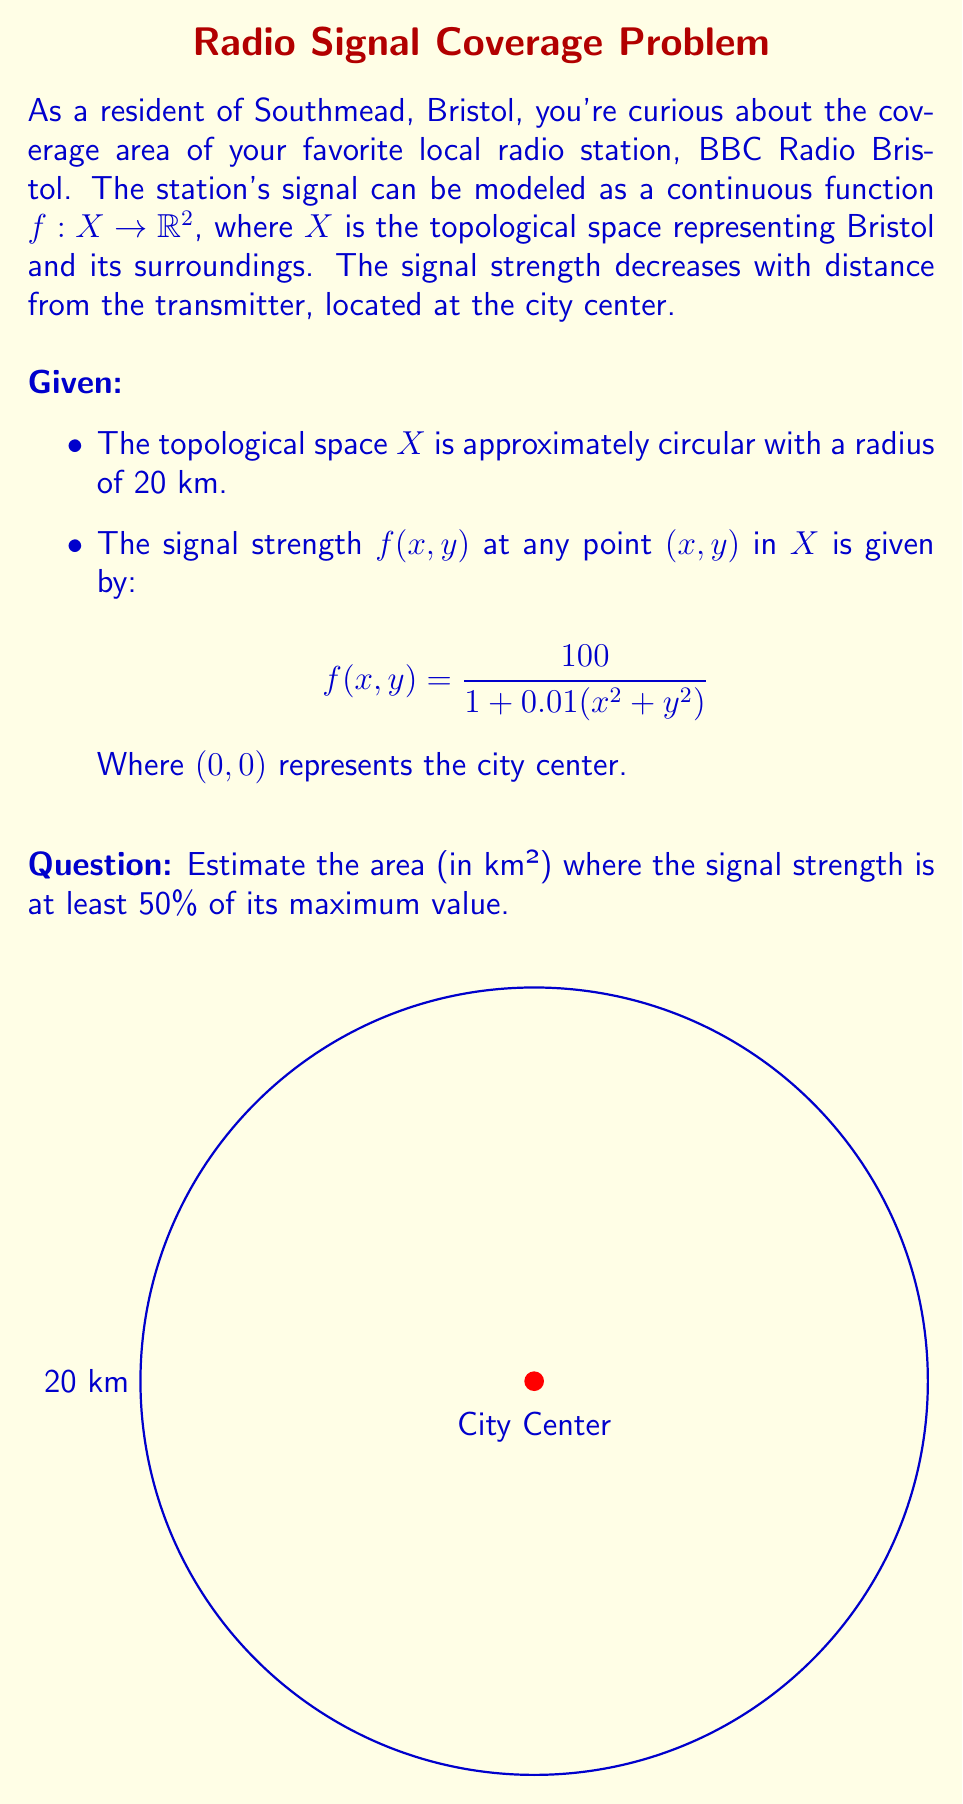Can you answer this question? Let's approach this step-by-step:

1) First, we need to find the maximum signal strength. This occurs at the city center (0,0):

   $$f(0,0) = \frac{100}{1 + 0.01(0^2 + 0^2)} = 100$$

2) We want to find the area where the signal strength is at least 50% of this maximum, so we're looking for points where:

   $$f(x,y) \geq 50$$

3) Let's solve this inequality:

   $$\frac{100}{1 + 0.01(x^2 + y^2)} \geq 50$$
   $$100 \geq 50(1 + 0.01(x^2 + y^2))$$
   $$2 \geq 1 + 0.01(x^2 + y^2)$$
   $$1 \geq 0.01(x^2 + y^2)$$
   $$100 \geq x^2 + y^2$$

4) This is the equation of a circle with radius $\sqrt{100} = 10$ km.

5) The area of this circle is:

   $$A = \pi r^2 = \pi (10)^2 = 100\pi \approx 314.16 \text{ km}^2$$

Therefore, the signal strength is at least 50% of its maximum value within a circular area of approximately 314.16 km² centered at the city center.
Answer: $314.16 \text{ km}^2$ 